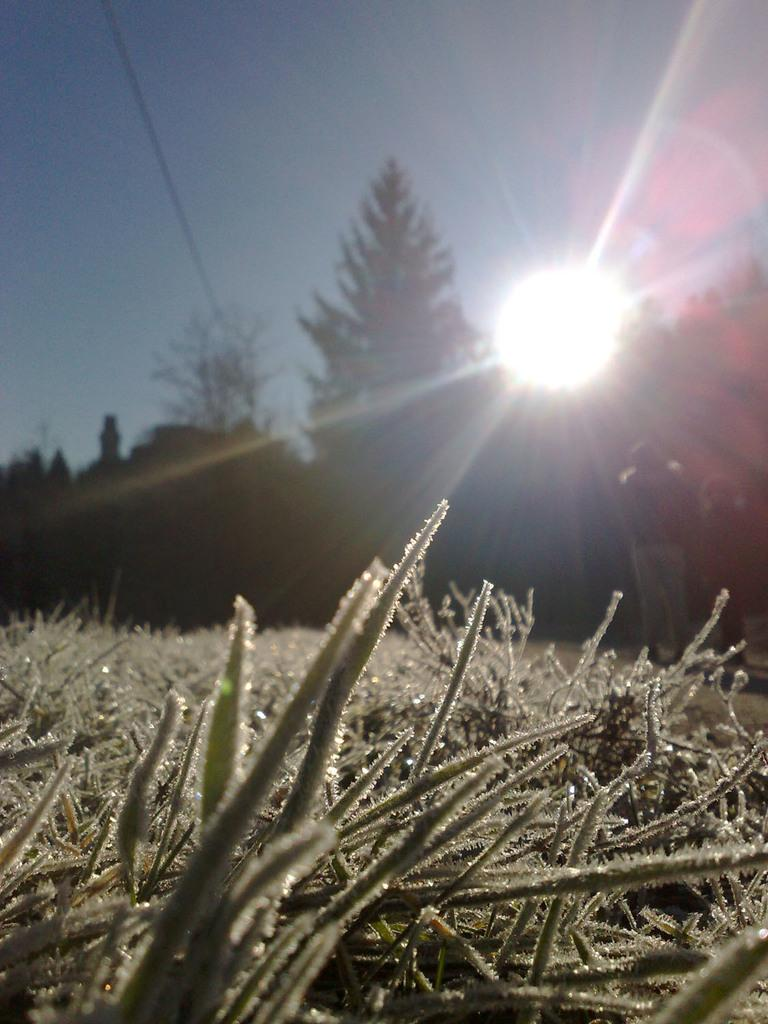What type of living organisms can be seen in the image? Plants are visible in the image. Can you describe the people in the image? There are persons standing near the trees in the background of the image. What is visible in the background of the image? The sky is visible in the background of the image. How would you describe the weather based on the image? The sky appears to be clear, suggesting good weather. What natural phenomenon is occurring in the image? There is a sunrise in the image. What type of key is being used to unlock the disease in the image? There is no key or disease present in the image; it features plants, persons, and a sunrise. 